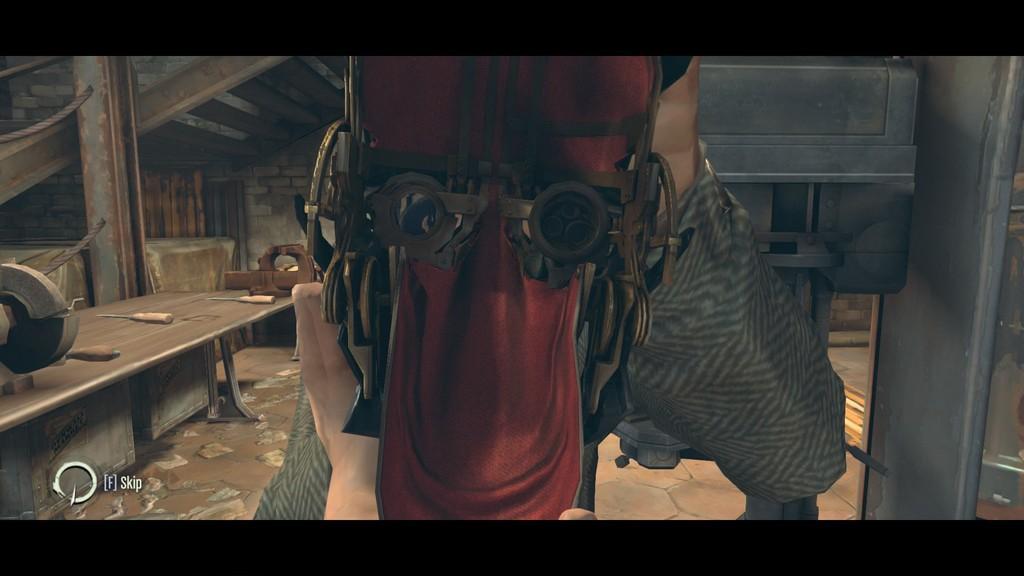Could you give a brief overview of what you see in this image? This is an animated picture. Here we can see a table, steps, and objects. On the table there are tools. At the bottom we can see a watermark. 